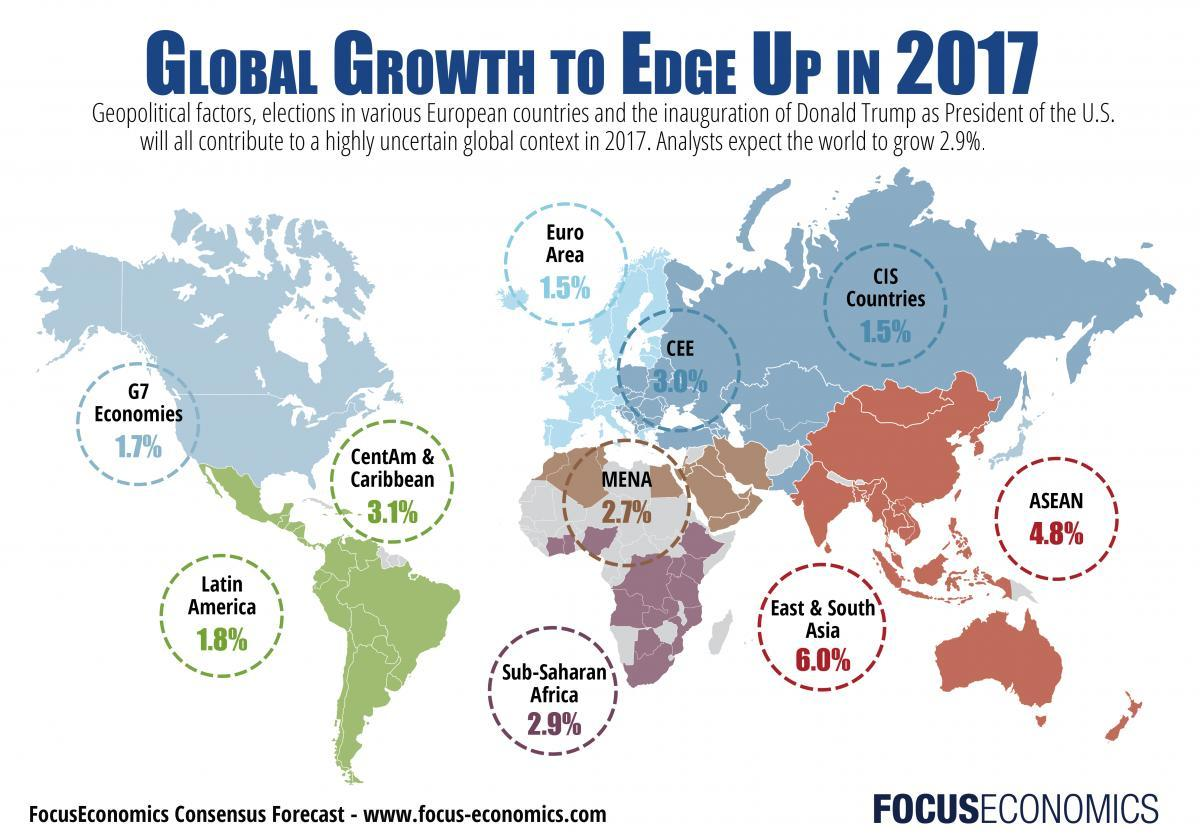Which regions have the same growth rate
Answer the question with a short phrase. Euro Area, CIS Countries What is the growth rate projects for MENA 2.7% Which region is expected to grow the most East & South Asia WHat is the growth rate projects for G7 economies 1.7% What is the difference in % between the lowest growth rate and the highest growth rate 4.5 How much lower in the growth rate in % of ASEAN than East & South Asia 1.2 